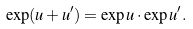Convert formula to latex. <formula><loc_0><loc_0><loc_500><loc_500>\exp ( u + u ^ { \prime } ) = \exp u \cdot \exp u ^ { \prime } .</formula> 